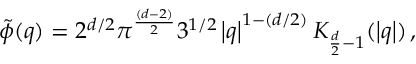<formula> <loc_0><loc_0><loc_500><loc_500>\tilde { \phi } ( q ) = 2 ^ { d / 2 } \pi ^ { \frac { ( d - 2 ) } { 2 } } 3 ^ { 1 / 2 } \left | q \right | ^ { 1 - ( d / 2 ) } K _ { \frac { d } { 2 } - 1 } ( \left | q \right | ) \, ,</formula> 